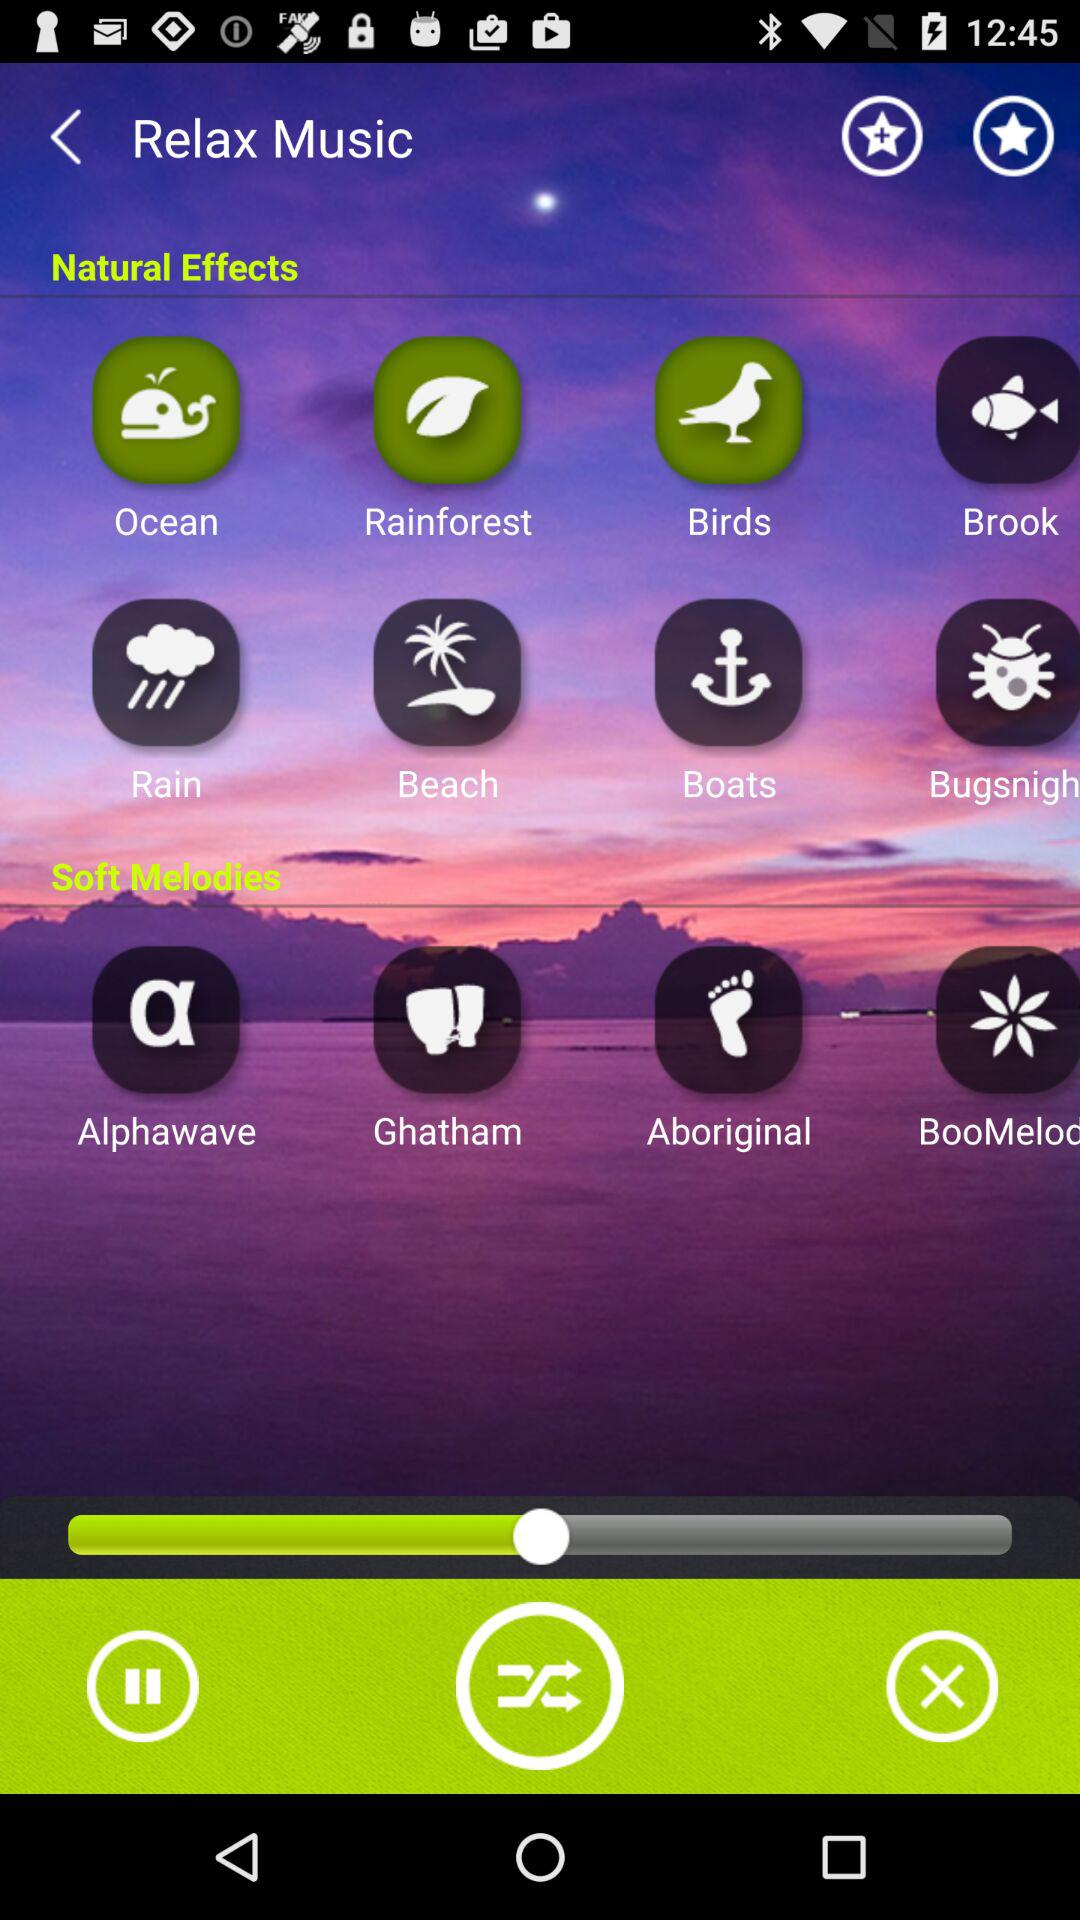What are the different types of soft melodies available? The different types of soft melodies are "Alphawave", "Ghatham" and "Aboriginal". 